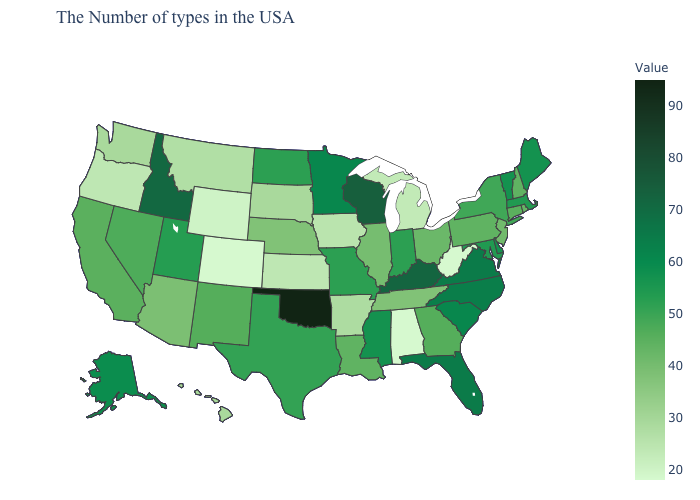Among the states that border Mississippi , which have the lowest value?
Answer briefly. Alabama. Which states have the lowest value in the MidWest?
Quick response, please. Michigan. Which states have the lowest value in the USA?
Short answer required. West Virginia, Alabama, Colorado. Among the states that border Oklahoma , does Colorado have the lowest value?
Write a very short answer. Yes. 